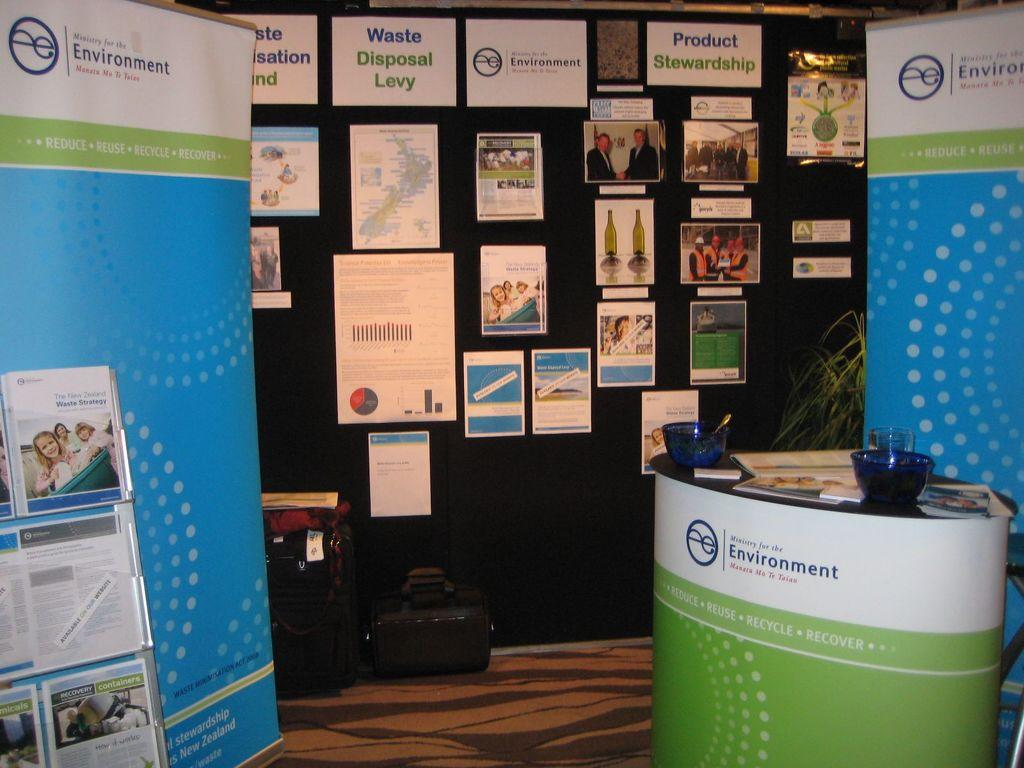Provide a one-sentence caption for the provided image. The Ministry of the Environment hosts a booth providing information on the waste disposal levy/. 